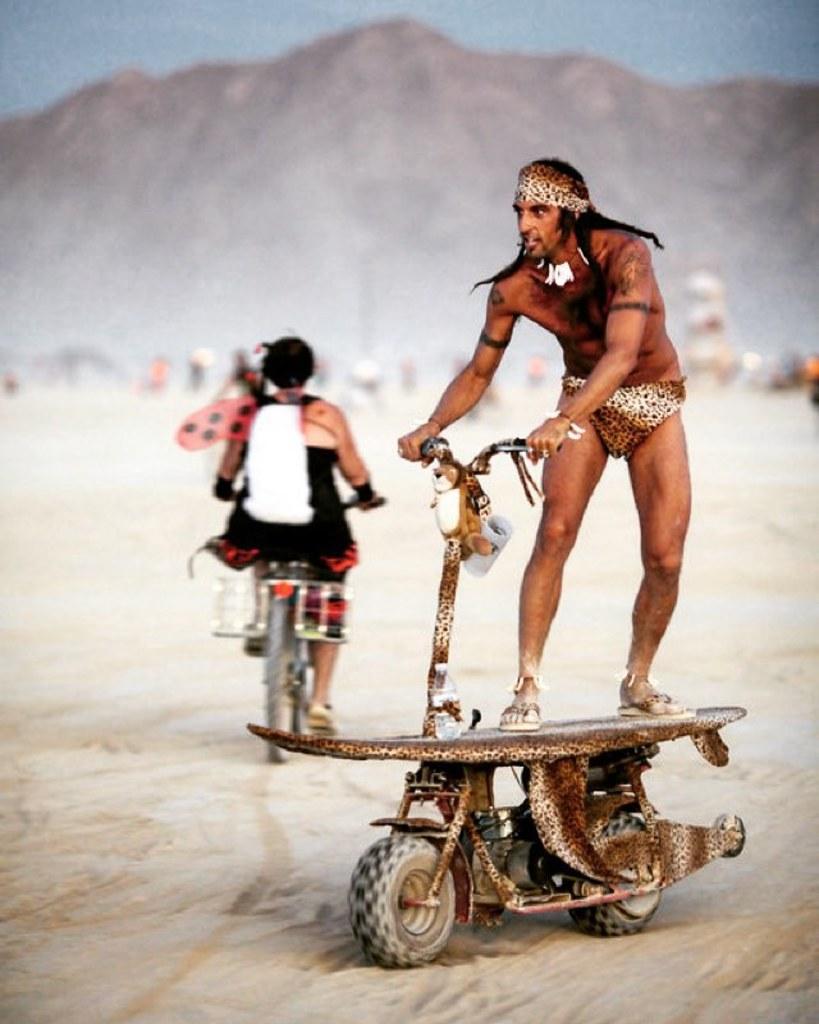Describe this image in one or two sentences. Here in this picture we can see a person in a costume riding a scooter that is present on the ground over there and behind him we can see other person riding bicycle over there and in the far we can see mountains present and we can also see other people present all in blurry manner over there. 